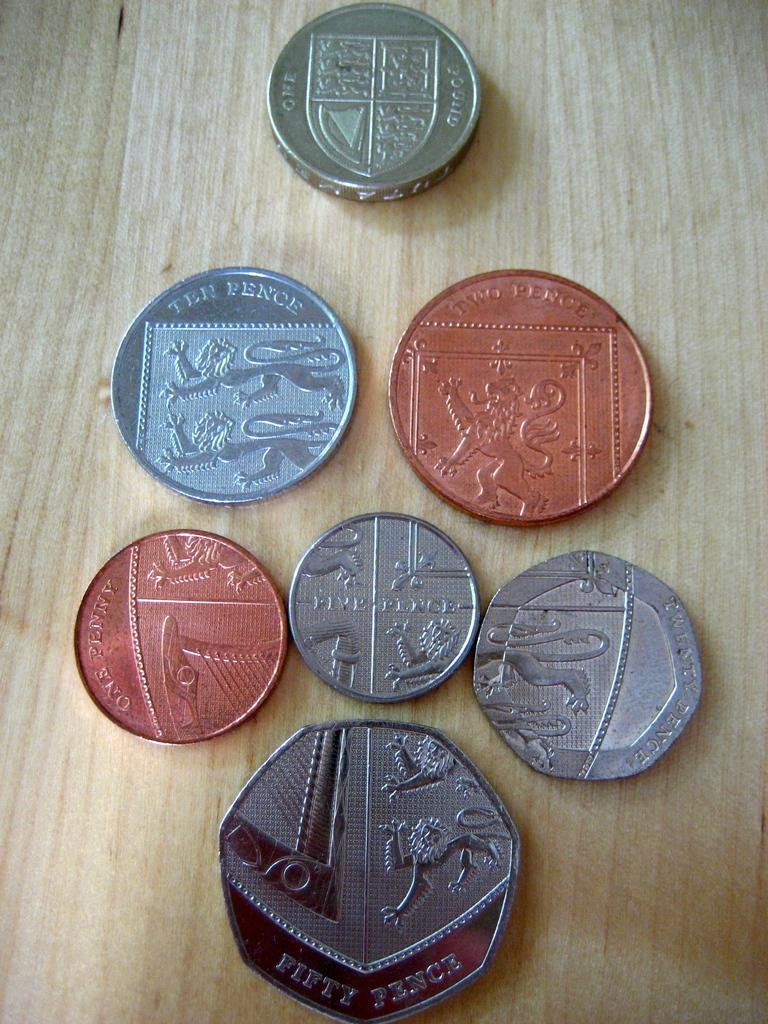<image>
Write a terse but informative summary of the picture. A group of European coins lined up to make a shield, with the bottom coin being worth fifty pence. 